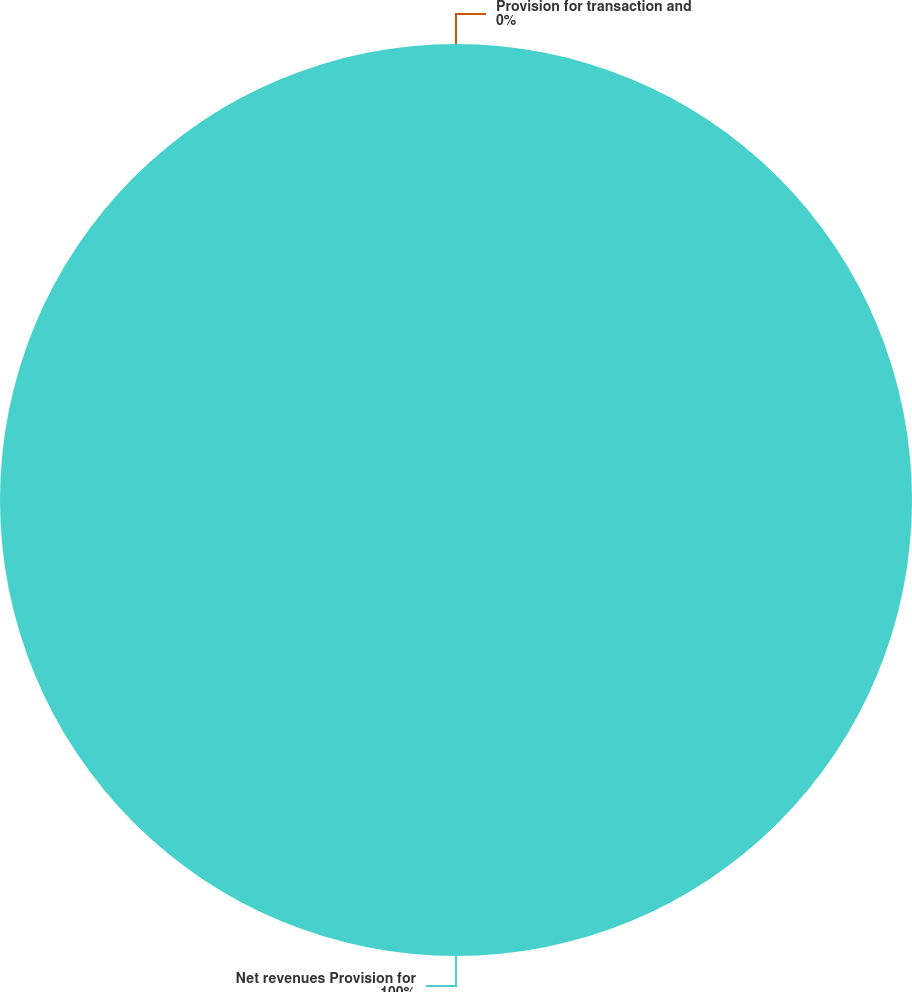Convert chart. <chart><loc_0><loc_0><loc_500><loc_500><pie_chart><fcel>Net revenues Provision for<fcel>Provision for transaction and<nl><fcel>100.0%<fcel>0.0%<nl></chart> 